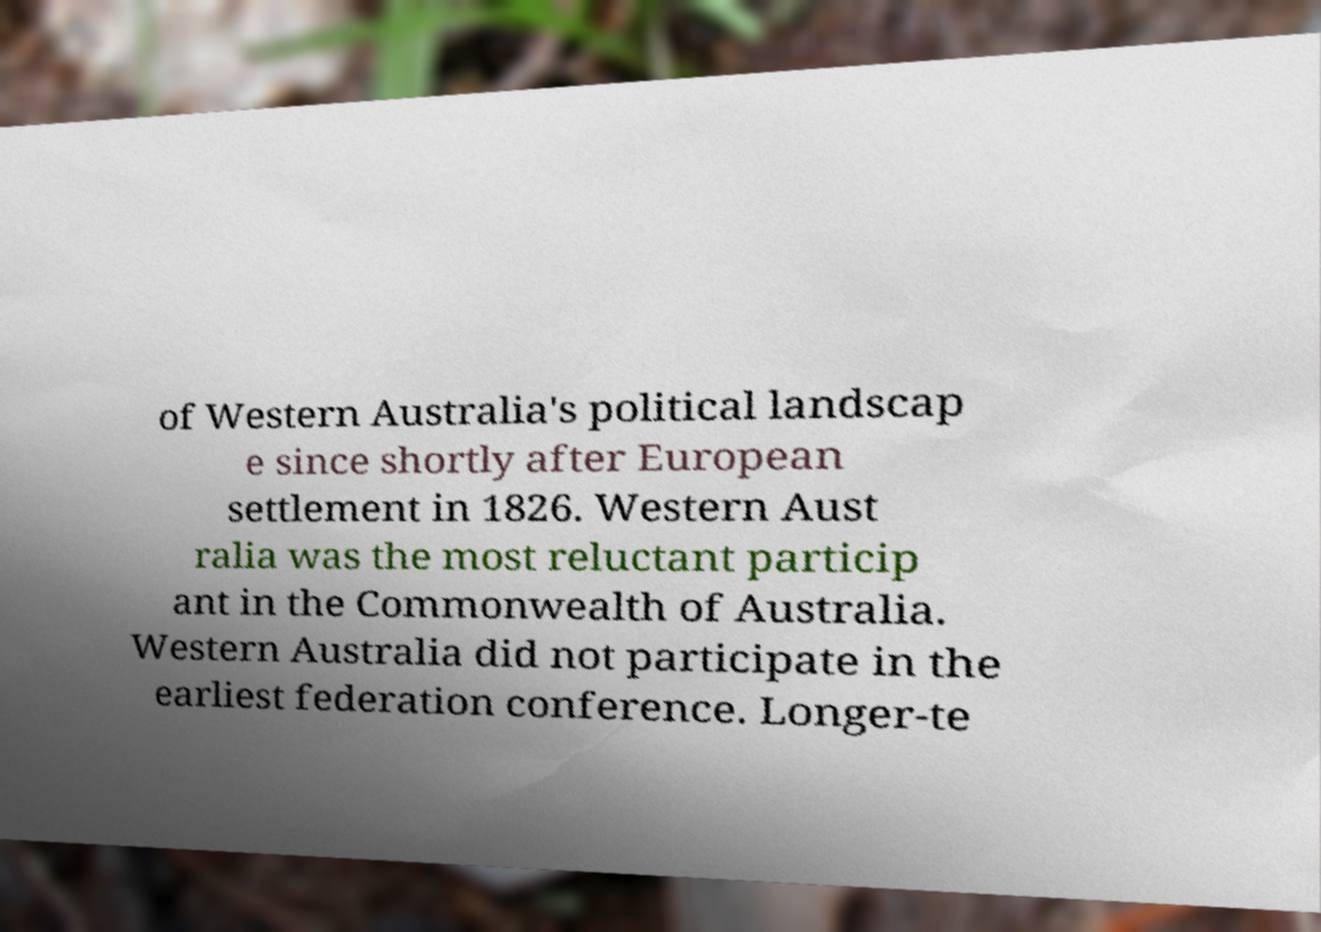Can you read and provide the text displayed in the image?This photo seems to have some interesting text. Can you extract and type it out for me? of Western Australia's political landscap e since shortly after European settlement in 1826. Western Aust ralia was the most reluctant particip ant in the Commonwealth of Australia. Western Australia did not participate in the earliest federation conference. Longer-te 